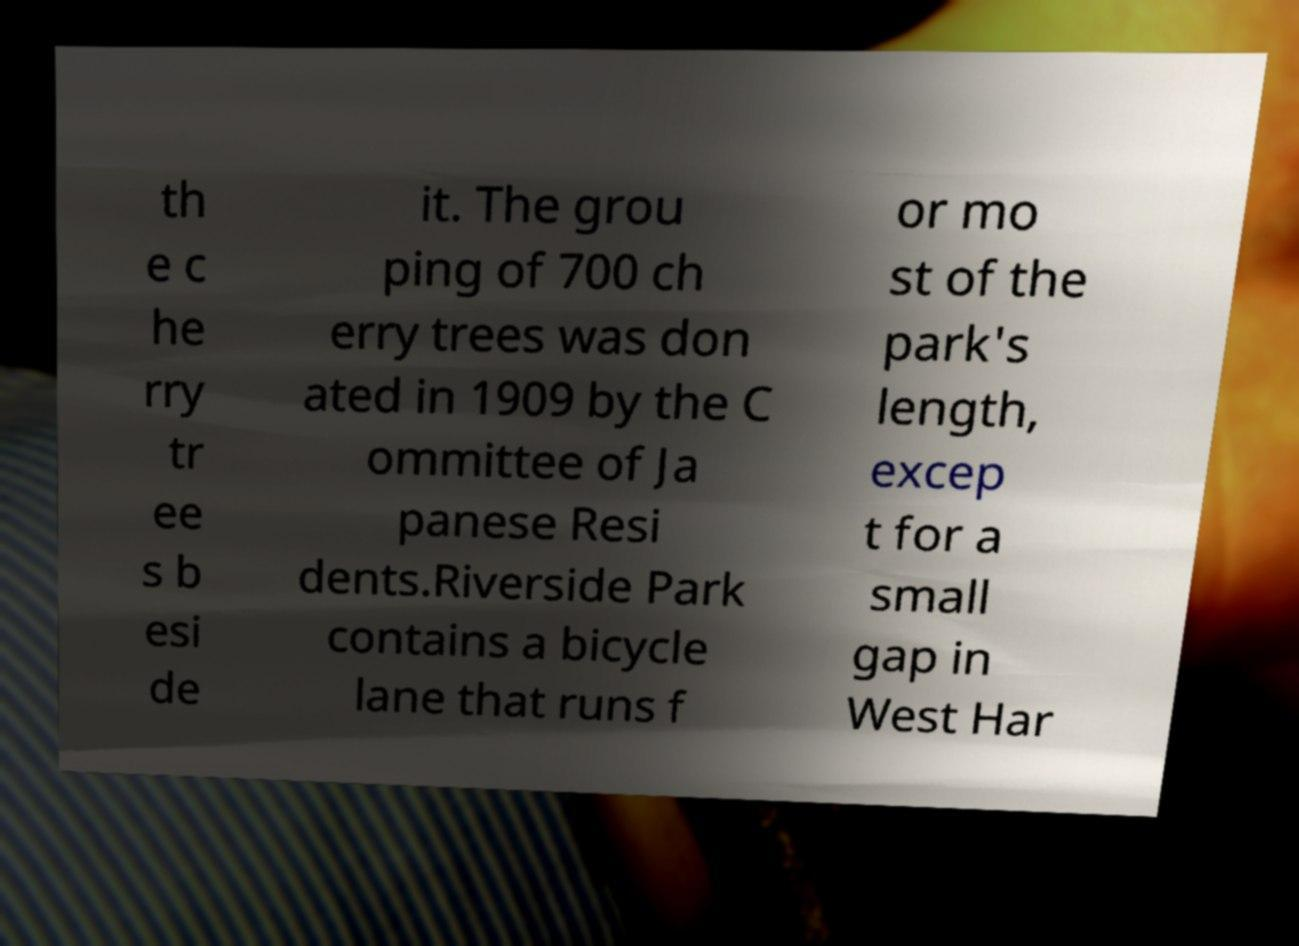For documentation purposes, I need the text within this image transcribed. Could you provide that? th e c he rry tr ee s b esi de it. The grou ping of 700 ch erry trees was don ated in 1909 by the C ommittee of Ja panese Resi dents.Riverside Park contains a bicycle lane that runs f or mo st of the park's length, excep t for a small gap in West Har 